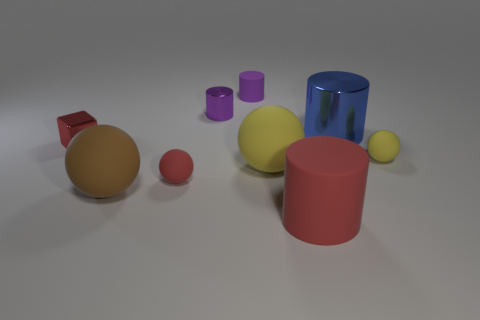The rubber object behind the large cylinder behind the metallic block is what shape? Based on the image, the rubber object positioned behind the large pink cylinder, which is itself behind the metallic block, appears to be spherical in shape. 